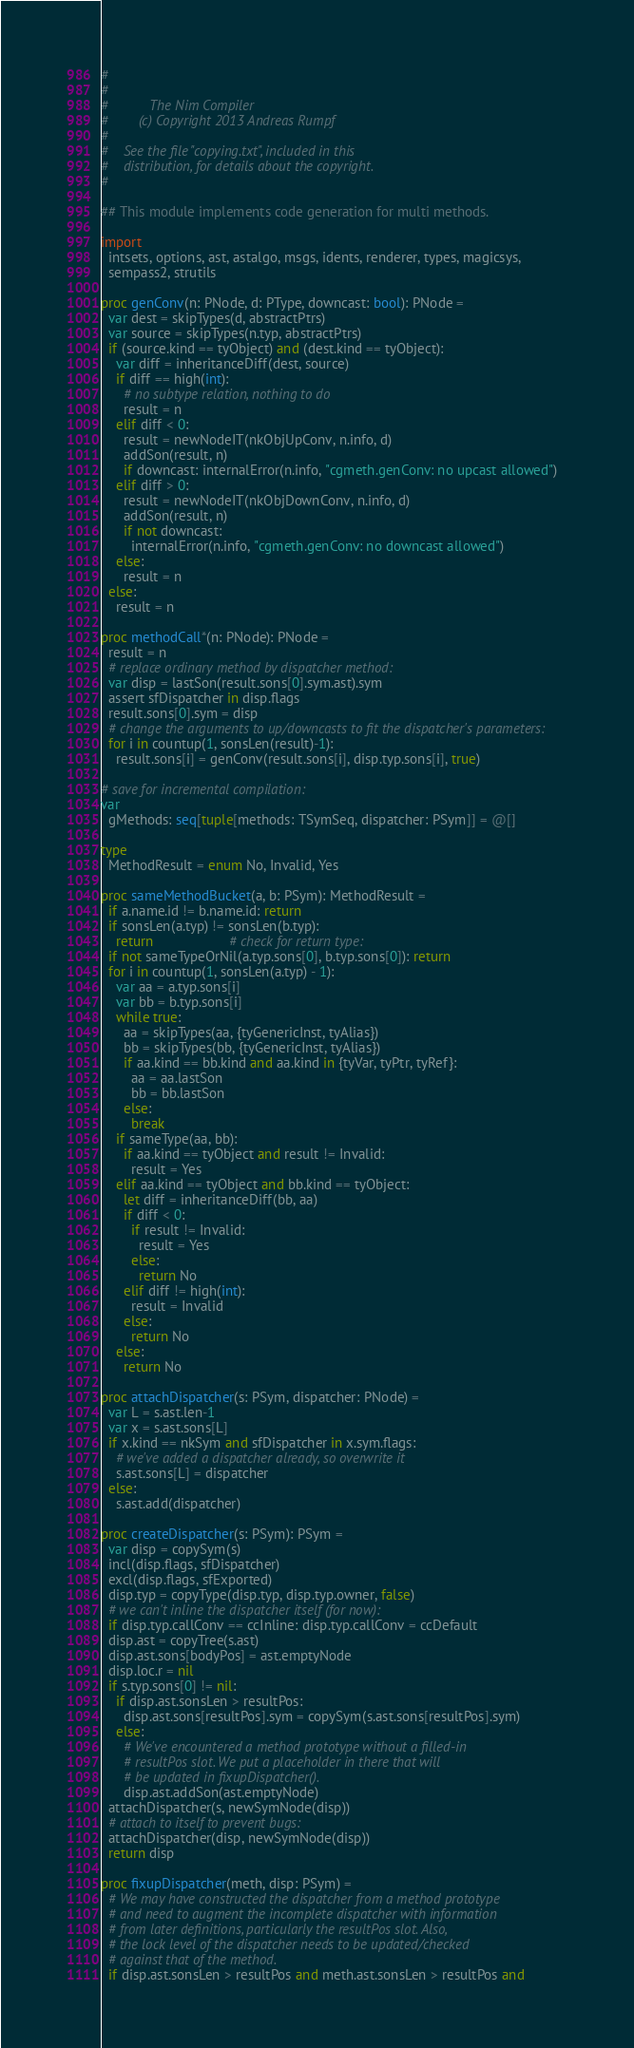<code> <loc_0><loc_0><loc_500><loc_500><_Nim_>#
#
#           The Nim Compiler
#        (c) Copyright 2013 Andreas Rumpf
#
#    See the file "copying.txt", included in this
#    distribution, for details about the copyright.
#

## This module implements code generation for multi methods.

import
  intsets, options, ast, astalgo, msgs, idents, renderer, types, magicsys,
  sempass2, strutils

proc genConv(n: PNode, d: PType, downcast: bool): PNode =
  var dest = skipTypes(d, abstractPtrs)
  var source = skipTypes(n.typ, abstractPtrs)
  if (source.kind == tyObject) and (dest.kind == tyObject):
    var diff = inheritanceDiff(dest, source)
    if diff == high(int):
      # no subtype relation, nothing to do
      result = n
    elif diff < 0:
      result = newNodeIT(nkObjUpConv, n.info, d)
      addSon(result, n)
      if downcast: internalError(n.info, "cgmeth.genConv: no upcast allowed")
    elif diff > 0:
      result = newNodeIT(nkObjDownConv, n.info, d)
      addSon(result, n)
      if not downcast:
        internalError(n.info, "cgmeth.genConv: no downcast allowed")
    else:
      result = n
  else:
    result = n

proc methodCall*(n: PNode): PNode =
  result = n
  # replace ordinary method by dispatcher method:
  var disp = lastSon(result.sons[0].sym.ast).sym
  assert sfDispatcher in disp.flags
  result.sons[0].sym = disp
  # change the arguments to up/downcasts to fit the dispatcher's parameters:
  for i in countup(1, sonsLen(result)-1):
    result.sons[i] = genConv(result.sons[i], disp.typ.sons[i], true)

# save for incremental compilation:
var
  gMethods: seq[tuple[methods: TSymSeq, dispatcher: PSym]] = @[]

type
  MethodResult = enum No, Invalid, Yes

proc sameMethodBucket(a, b: PSym): MethodResult =
  if a.name.id != b.name.id: return
  if sonsLen(a.typ) != sonsLen(b.typ):
    return                    # check for return type:
  if not sameTypeOrNil(a.typ.sons[0], b.typ.sons[0]): return
  for i in countup(1, sonsLen(a.typ) - 1):
    var aa = a.typ.sons[i]
    var bb = b.typ.sons[i]
    while true:
      aa = skipTypes(aa, {tyGenericInst, tyAlias})
      bb = skipTypes(bb, {tyGenericInst, tyAlias})
      if aa.kind == bb.kind and aa.kind in {tyVar, tyPtr, tyRef}:
        aa = aa.lastSon
        bb = bb.lastSon
      else:
        break
    if sameType(aa, bb):
      if aa.kind == tyObject and result != Invalid:
        result = Yes
    elif aa.kind == tyObject and bb.kind == tyObject:
      let diff = inheritanceDiff(bb, aa)
      if diff < 0:
        if result != Invalid:
          result = Yes
        else:
          return No
      elif diff != high(int):
        result = Invalid
      else:
        return No
    else:
      return No

proc attachDispatcher(s: PSym, dispatcher: PNode) =
  var L = s.ast.len-1
  var x = s.ast.sons[L]
  if x.kind == nkSym and sfDispatcher in x.sym.flags:
    # we've added a dispatcher already, so overwrite it
    s.ast.sons[L] = dispatcher
  else:
    s.ast.add(dispatcher)

proc createDispatcher(s: PSym): PSym =
  var disp = copySym(s)
  incl(disp.flags, sfDispatcher)
  excl(disp.flags, sfExported)
  disp.typ = copyType(disp.typ, disp.typ.owner, false)
  # we can't inline the dispatcher itself (for now):
  if disp.typ.callConv == ccInline: disp.typ.callConv = ccDefault
  disp.ast = copyTree(s.ast)
  disp.ast.sons[bodyPos] = ast.emptyNode
  disp.loc.r = nil
  if s.typ.sons[0] != nil:
    if disp.ast.sonsLen > resultPos:
      disp.ast.sons[resultPos].sym = copySym(s.ast.sons[resultPos].sym)
    else:
      # We've encountered a method prototype without a filled-in
      # resultPos slot. We put a placeholder in there that will
      # be updated in fixupDispatcher().
      disp.ast.addSon(ast.emptyNode)
  attachDispatcher(s, newSymNode(disp))
  # attach to itself to prevent bugs:
  attachDispatcher(disp, newSymNode(disp))
  return disp

proc fixupDispatcher(meth, disp: PSym) =
  # We may have constructed the dispatcher from a method prototype
  # and need to augment the incomplete dispatcher with information
  # from later definitions, particularly the resultPos slot. Also,
  # the lock level of the dispatcher needs to be updated/checked
  # against that of the method.
  if disp.ast.sonsLen > resultPos and meth.ast.sonsLen > resultPos and</code> 